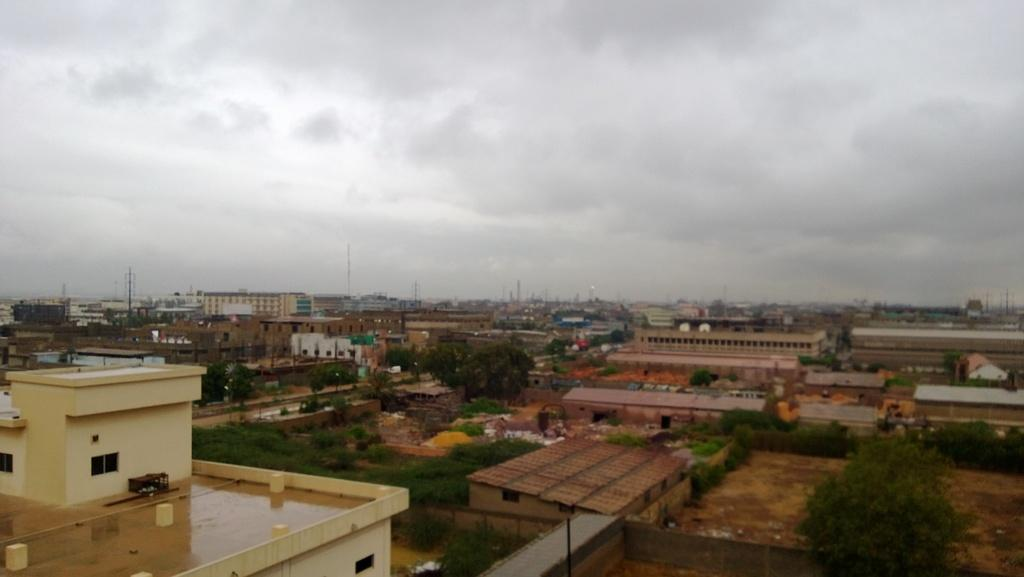What is the main subject of the image? The main subject of the image is an overview of a city. What types of structures can be seen in the image? There are buildings in the image. What other objects are present in the image? There are poles, a fence, and trees in the image. What is the condition of the sky in the image? The sky is covered with clouds at the top of the image. What type of coil is being used to prepare the feast in the image? There is no feast or coil present in the image; it is an overview of a city with various structures and objects. What request is being made by the person in the image? There is no person or request present in the image; it is an overview of a city with various structures and objects. 